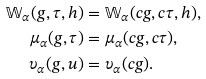<formula> <loc_0><loc_0><loc_500><loc_500>\mathbb { W } _ { \alpha } ( g , \tau , h ) & = \mathbb { W } _ { \alpha } ( c g , c \tau , h ) , \\ \mu _ { \alpha } ( g , \tau ) & = \mu _ { \alpha } ( c g , c \tau ) , \\ \upsilon _ { \alpha } ( g , u ) & = \upsilon _ { \alpha } ( c g ) .</formula> 